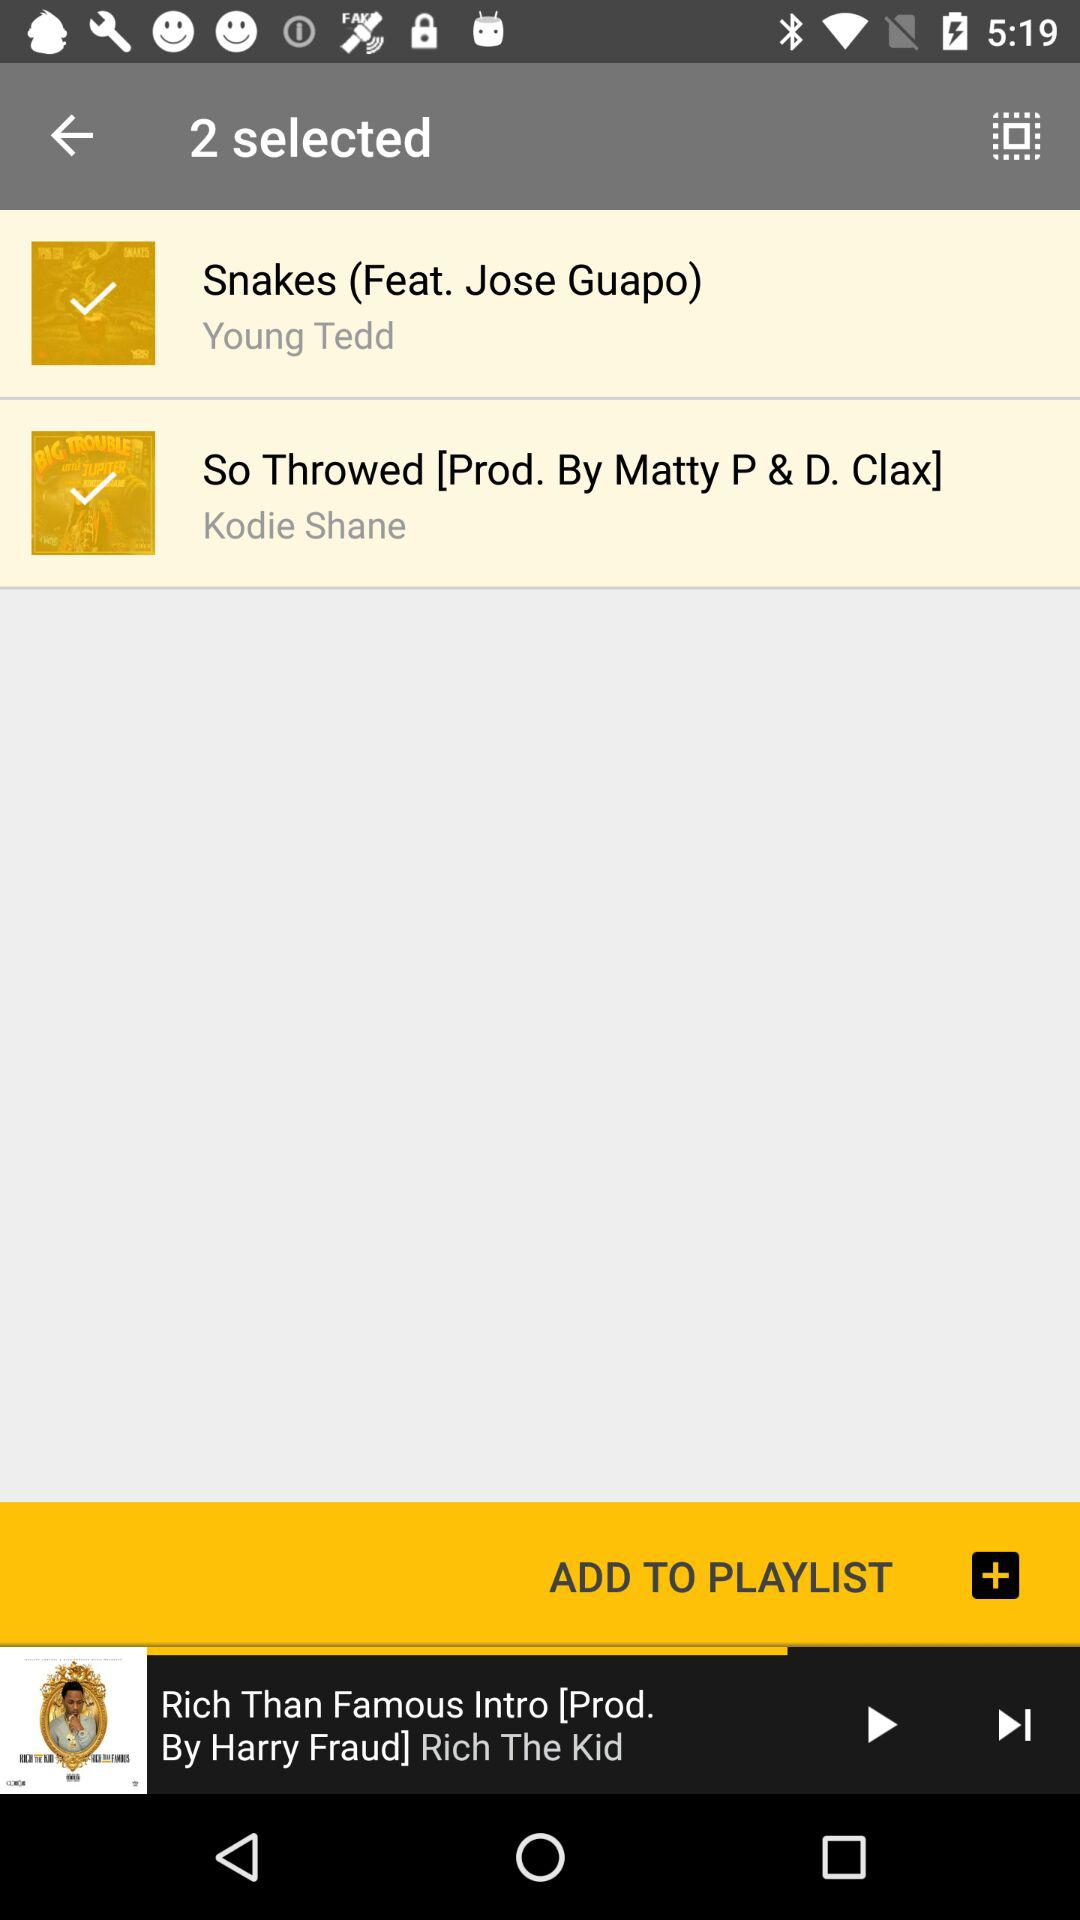Who is the artist of "Snakes"? The artists of "Snakes" are Jose Guapo and Young Tedd. 